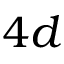<formula> <loc_0><loc_0><loc_500><loc_500>4 d</formula> 